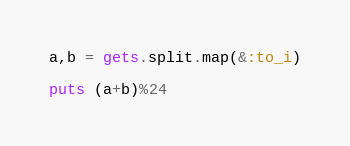<code> <loc_0><loc_0><loc_500><loc_500><_Ruby_>a,b = gets.split.map(&:to_i)

puts (a+b)%24</code> 